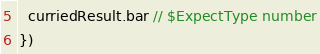<code> <loc_0><loc_0><loc_500><loc_500><_TypeScript_>  curriedResult.bar // $ExpectType number
})
</code> 